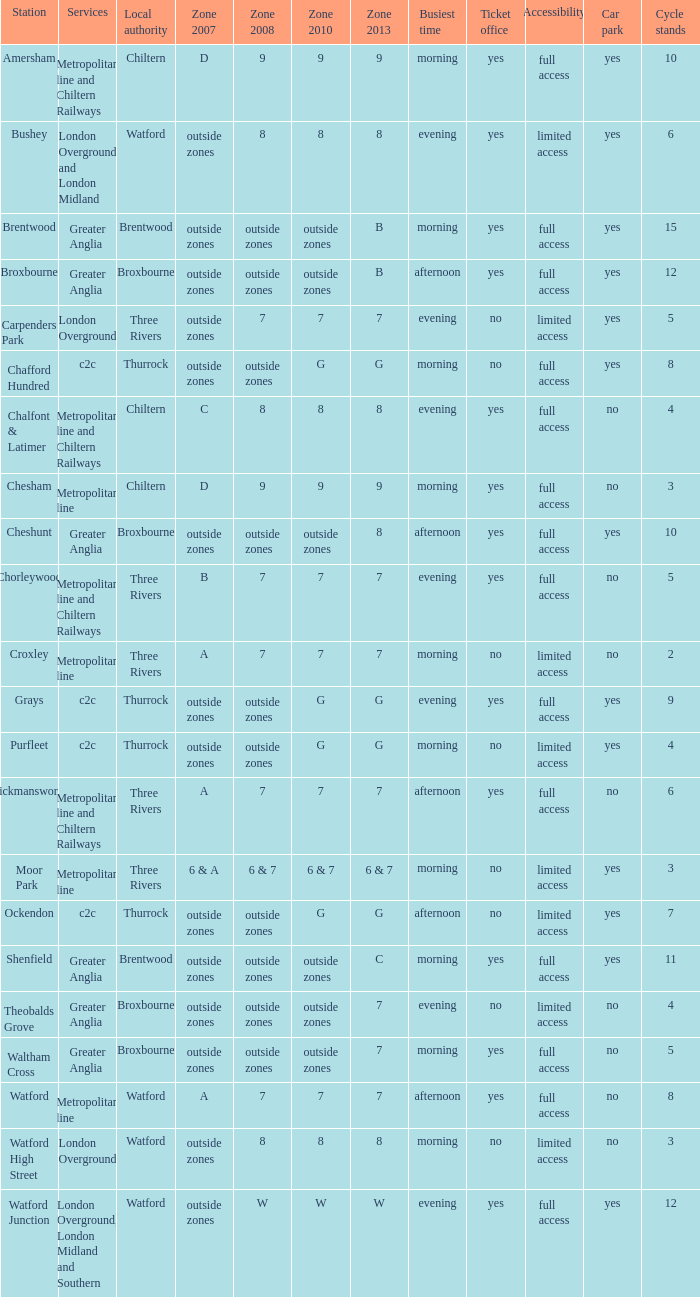Which Station has a Zone 2010 of 7? Carpenders Park, Chorleywood, Croxley, Rickmansworth, Watford. 